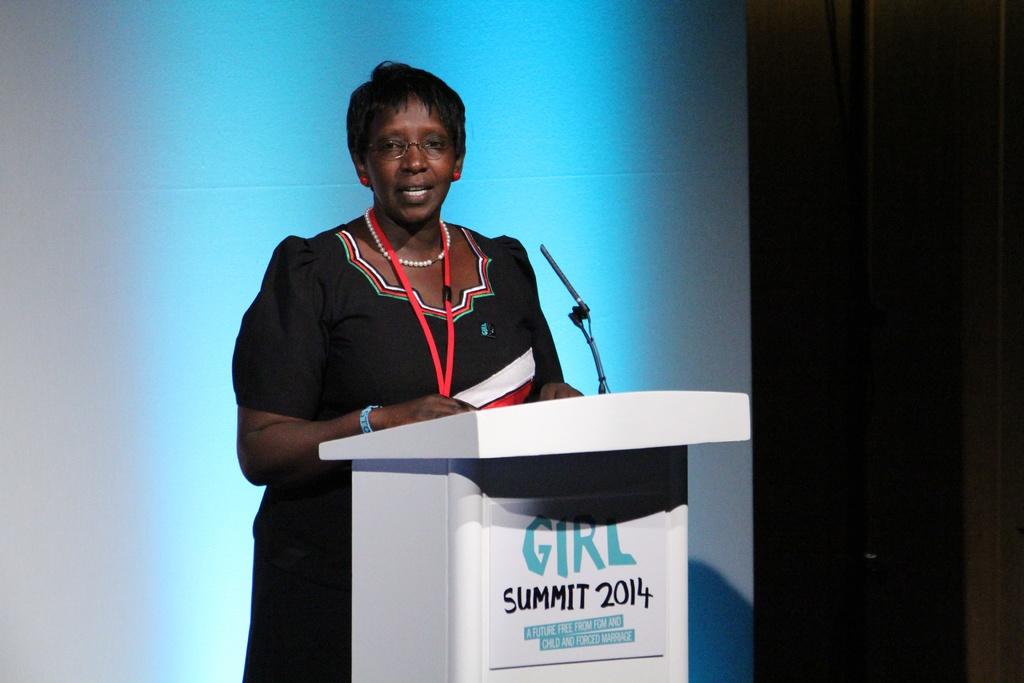What is the name of this event?
Your answer should be compact. Girl summit 2014. 